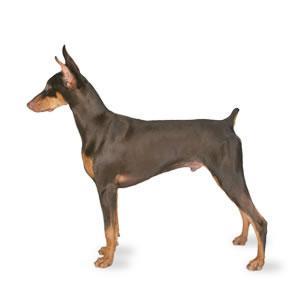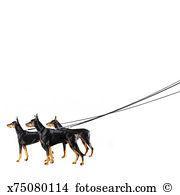The first image is the image on the left, the second image is the image on the right. Given the left and right images, does the statement "there is a keychain with3 dogs on it" hold true? Answer yes or no. No. The first image is the image on the left, the second image is the image on the right. For the images shown, is this caption "One image shows a silver keychain featuring a dog theme, and the other image contains a white rectangle with a dog theme." true? Answer yes or no. No. 